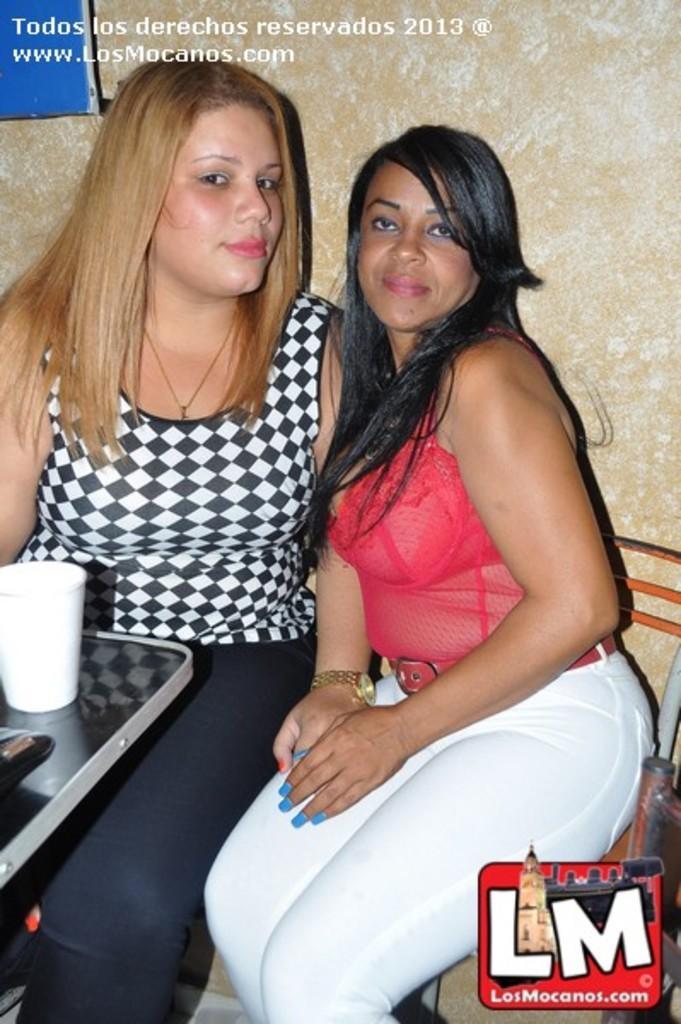Could you give a brief overview of what you see in this image? In the image we can see there are two women sitting. This is a table and glass is kept on the table. This is a watermark. 